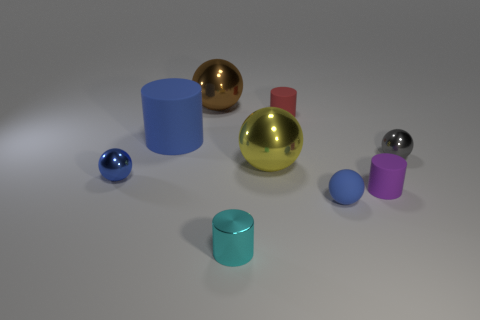Is the material of the large blue cylinder the same as the tiny cyan object?
Your answer should be compact. No. What number of objects are red objects or large matte cubes?
Provide a succinct answer. 1. What shape is the tiny blue object to the right of the tiny red matte cylinder?
Provide a succinct answer. Sphere. What is the color of the other large thing that is the same material as the red thing?
Provide a short and direct response. Blue. What is the material of the big object that is the same shape as the small red thing?
Offer a terse response. Rubber. What shape is the red rubber object?
Provide a short and direct response. Cylinder. There is a cylinder that is in front of the red thing and on the right side of the cyan metallic cylinder; what is it made of?
Make the answer very short. Rubber. There is a large yellow thing that is made of the same material as the cyan cylinder; what is its shape?
Your answer should be compact. Sphere. There is a brown thing that is the same material as the yellow thing; what size is it?
Offer a terse response. Large. The metal thing that is right of the brown thing and in front of the large yellow ball has what shape?
Your answer should be very brief. Cylinder. 